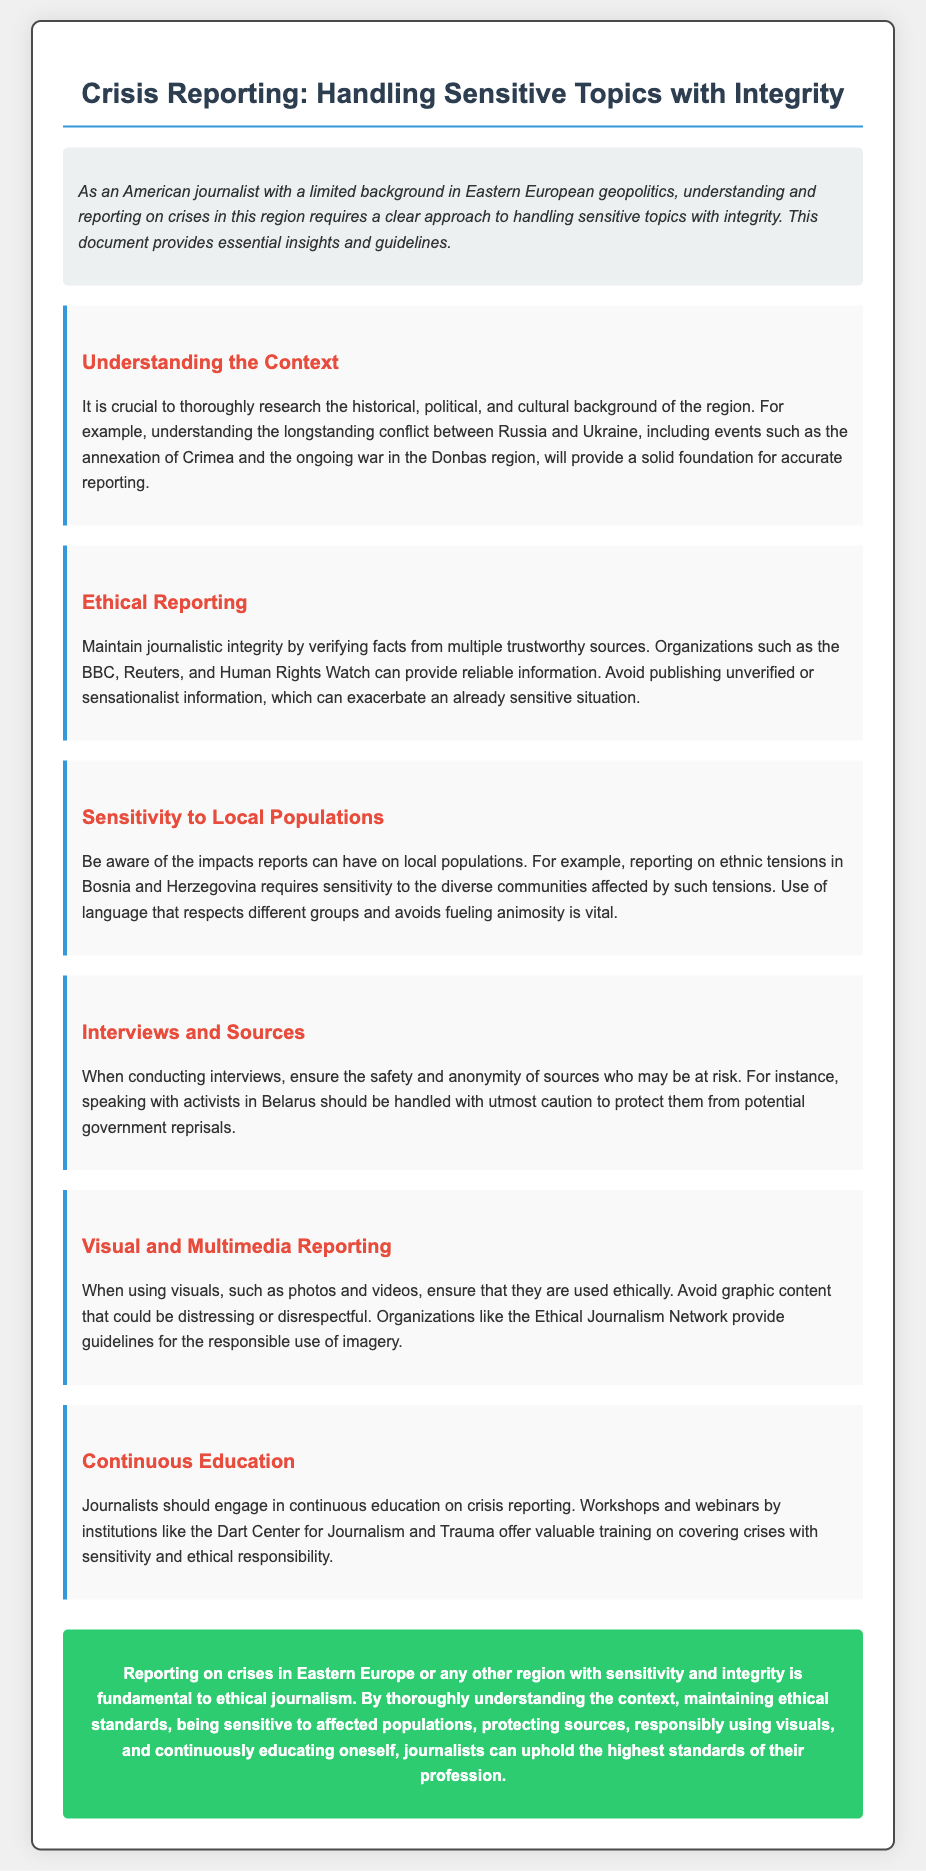What is the title of the diploma? The title of the diploma is stated prominently at the top of the document.
Answer: Crisis Reporting: Handling Sensitive Topics with Integrity Which organization is mentioned as a reliable source for verification? The document lists organizations that provide trustworthy information for verifying facts.
Answer: BBC What is the focus of the "Understanding the Context" section? This section emphasizes the importance of knowing the historical and political background of the region.
Answer: Historical, political, and cultural background What type of reporting should be avoided according to the "Ethical Reporting" section? The document advises against a certain type of reporting that could worsen sensitive situations.
Answer: Sensationalist information What should journalists ensure when conducting interviews with at-risk sources? The document mentions key considerations for journalists when speaking with vulnerable sources.
Answer: Safety and anonymity What organization offers training on covering crises with sensitivity? The document refers to an institution that provides valuable training for journalists.
Answer: Dart Center for Journalism and Trauma What is the primary goal of the diploma document? The document outlines the fundamental objective regarding crisis reporting.
Answer: Ethical journalism What is the background color of the "intro" section? The visual design of the document specifies the color used for the introduction section.
Answer: Light gray (or #ecf0f1) Which country’s ethnic tensions are discussed in the context of sensitivity? The document provides an example involving ethnic tensions relevant to a specific country.
Answer: Bosnia and Herzegovina 